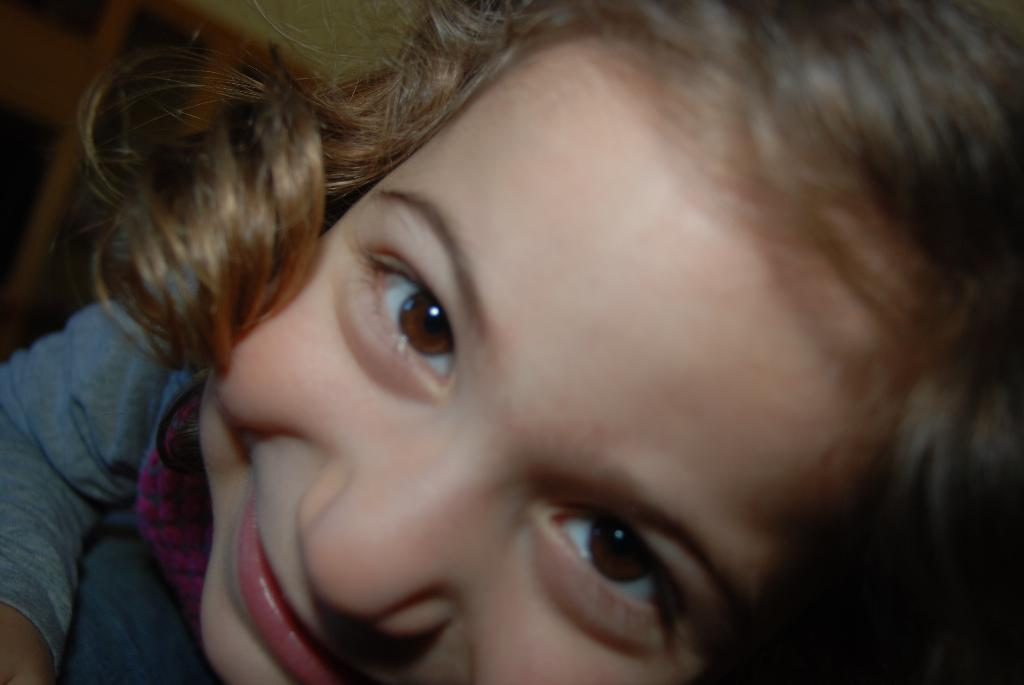Who is the main subject in the picture? There is a girl in the picture. What type of underwear is the girl wearing in the picture? There is no information about the girl's underwear in the image, so it cannot be determined. 